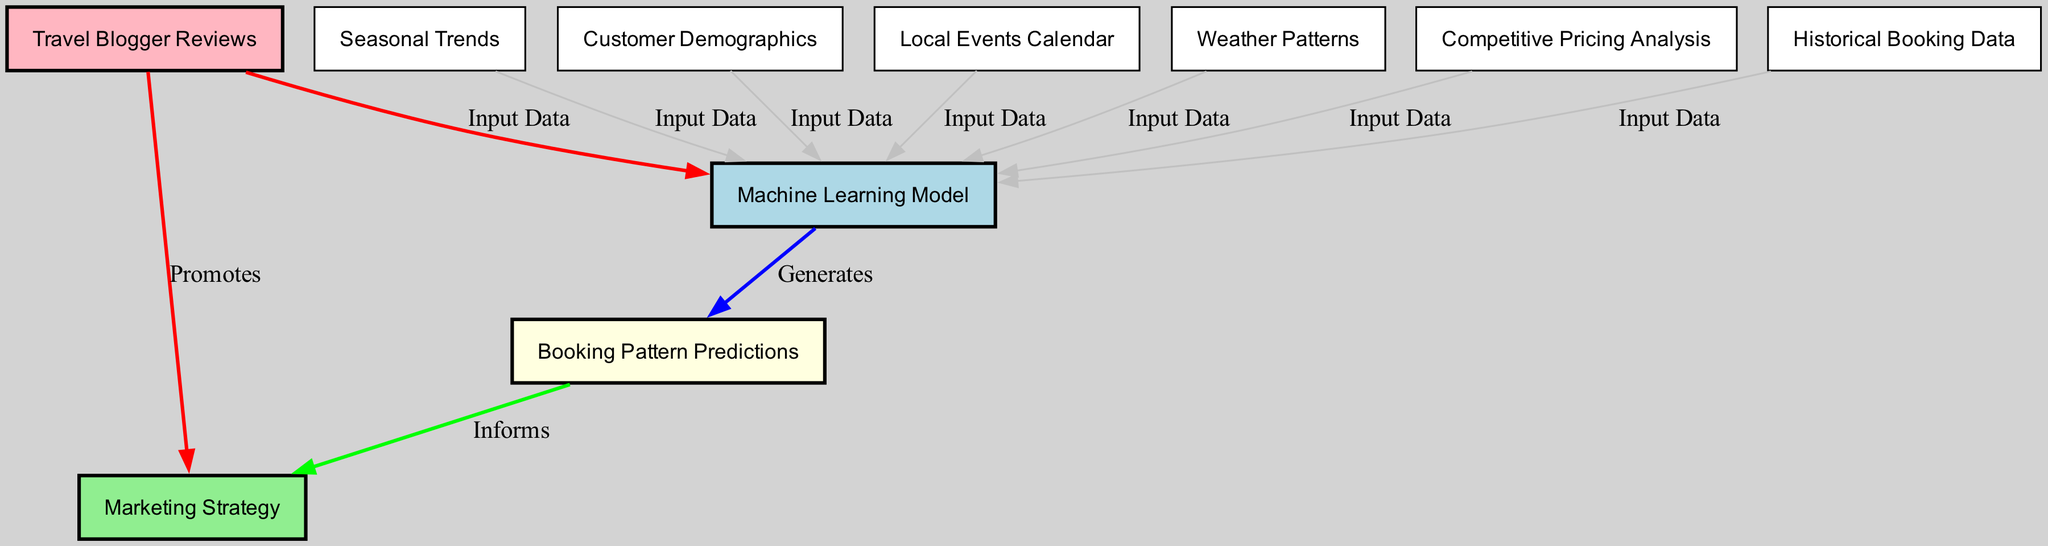What is the central node in the diagram? The central node is the "Machine Learning Model," which receives inputs from various other nodes. It represents the core processing component of the diagram.
Answer: Machine Learning Model How many input data nodes contribute to the "Machine Learning Model"? There are six input data nodes that contribute information to the "Machine Learning Model." These nodes include Historical Booking Data, Seasonal Trends, Customer Demographics, Local Events Calendar, Weather Patterns, and Competitive Pricing Analysis.
Answer: 6 Which node directly promotes the "Marketing Strategy"? The node "Travel Blogger Reviews" directly promotes the "Marketing Strategy" according to the diagram's outgoing edge.
Answer: Travel Blogger Reviews What type of data does the "Competitive Pricing Analysis" node provide? The "Competitive Pricing Analysis" node provides input data to the "Machine Learning Model," contributing to the overall analysis of booking patterns.
Answer: Input Data How do the "Booking Pattern Predictions" inform the "Marketing Strategy"? The "Booking Pattern Predictions" inform the "Marketing Strategy" by providing insights into expected future trends, which helps tailor marketing efforts.
Answer: Informs Which two nodes share a direct connection to the "Machine Learning Model"? The "Historical Booking Data" and "Local Events Calendar" nodes both share direct connections to the "Machine Learning Model" as sources of input data.
Answer: Historical Booking Data, Local Events Calendar How many total edges are there in the diagram? The total number of edges in the diagram is ten, representing the relationships between the nodes.
Answer: 10 What color represents the "Booking Pattern Predictions" node? The "Booking Pattern Predictions" node is represented in light yellow, distinguishing it from other nodes in the diagram.
Answer: Light Yellow Which node is linked to both "Booking Pattern Predictions" and "Marketing Strategy"? The "Booking Pattern Predictions" node is linked to the "Marketing Strategy" node, directing insights from predictions to marketing efforts.
Answer: Booking Pattern Predictions 